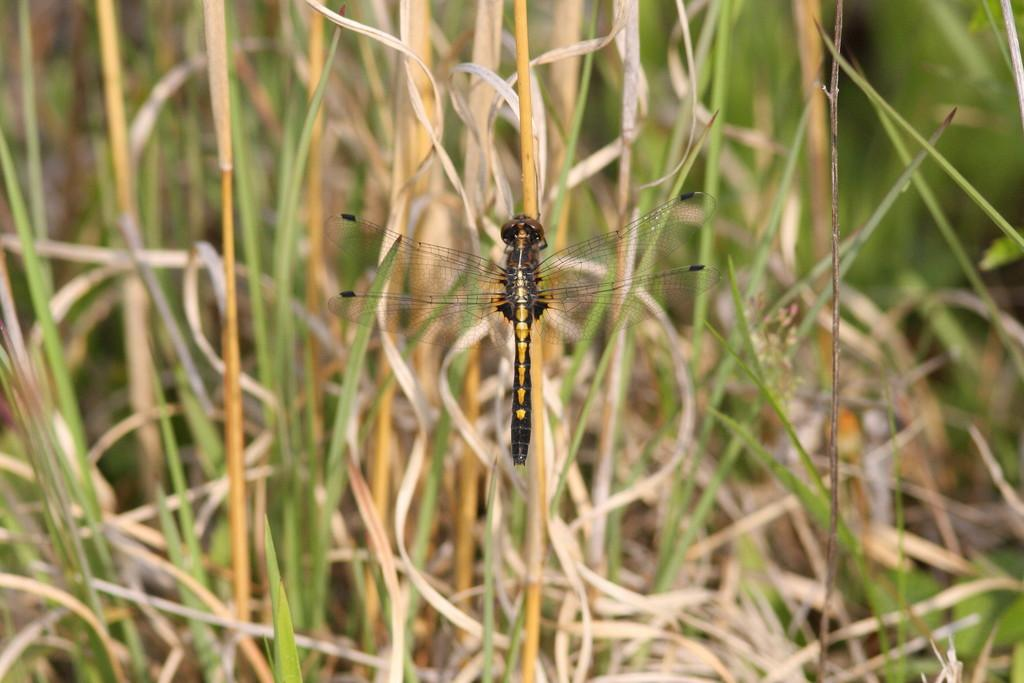What is the main subject of the image? There is a dragonfly in the center of the image. What can be seen in the background of the image? There is grass in the background of the image. What type of mark does the dragonfly leave on the grass in the image? There is no indication in the image that the dragonfly leaves any mark on the grass. 